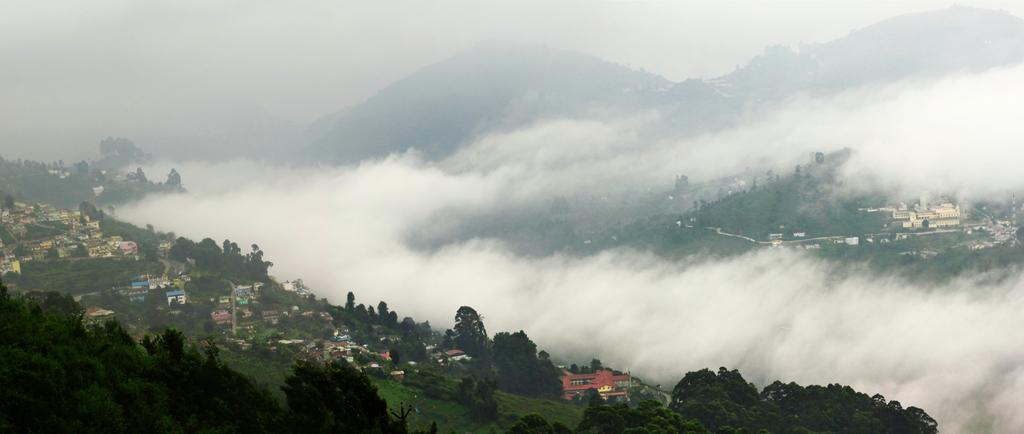What can be seen at the top of the image? The sky is visible towards the top of the image. What type of natural landforms are present in the image? There are mountains in the image. What is the weather condition in the image? There is fog in the image. What type of vegetation is present in the image? There are trees in the image. What type of man-made structures are present in the image? There are buildings in the image. What type of ground cover is present in the image? There is grass in the image. What type of oil is being advertised on the side of the mountain in the image? There is no advertisement or oil present in the image; it features mountains, fog, trees, buildings, and grass. 